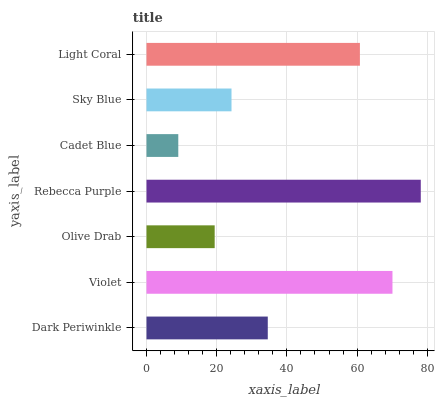Is Cadet Blue the minimum?
Answer yes or no. Yes. Is Rebecca Purple the maximum?
Answer yes or no. Yes. Is Violet the minimum?
Answer yes or no. No. Is Violet the maximum?
Answer yes or no. No. Is Violet greater than Dark Periwinkle?
Answer yes or no. Yes. Is Dark Periwinkle less than Violet?
Answer yes or no. Yes. Is Dark Periwinkle greater than Violet?
Answer yes or no. No. Is Violet less than Dark Periwinkle?
Answer yes or no. No. Is Dark Periwinkle the high median?
Answer yes or no. Yes. Is Dark Periwinkle the low median?
Answer yes or no. Yes. Is Olive Drab the high median?
Answer yes or no. No. Is Sky Blue the low median?
Answer yes or no. No. 